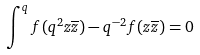<formula> <loc_0><loc_0><loc_500><loc_500>\int ^ { q } f ( q ^ { 2 } z \overline { z } ) - q ^ { - 2 } f ( z \overline { z } ) = 0</formula> 